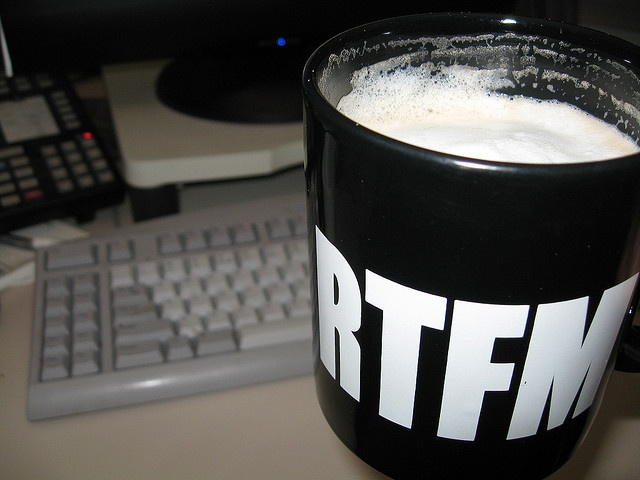Describe the objects in this image and their specific colors. I can see cup in black, lightgray, darkgray, and gray tones and keyboard in black and gray tones in this image. 